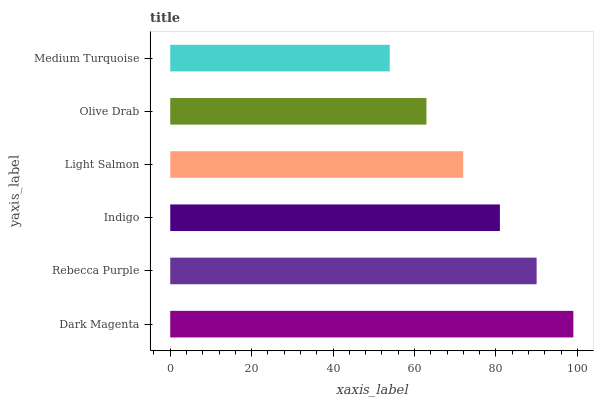Is Medium Turquoise the minimum?
Answer yes or no. Yes. Is Dark Magenta the maximum?
Answer yes or no. Yes. Is Rebecca Purple the minimum?
Answer yes or no. No. Is Rebecca Purple the maximum?
Answer yes or no. No. Is Dark Magenta greater than Rebecca Purple?
Answer yes or no. Yes. Is Rebecca Purple less than Dark Magenta?
Answer yes or no. Yes. Is Rebecca Purple greater than Dark Magenta?
Answer yes or no. No. Is Dark Magenta less than Rebecca Purple?
Answer yes or no. No. Is Indigo the high median?
Answer yes or no. Yes. Is Light Salmon the low median?
Answer yes or no. Yes. Is Medium Turquoise the high median?
Answer yes or no. No. Is Medium Turquoise the low median?
Answer yes or no. No. 